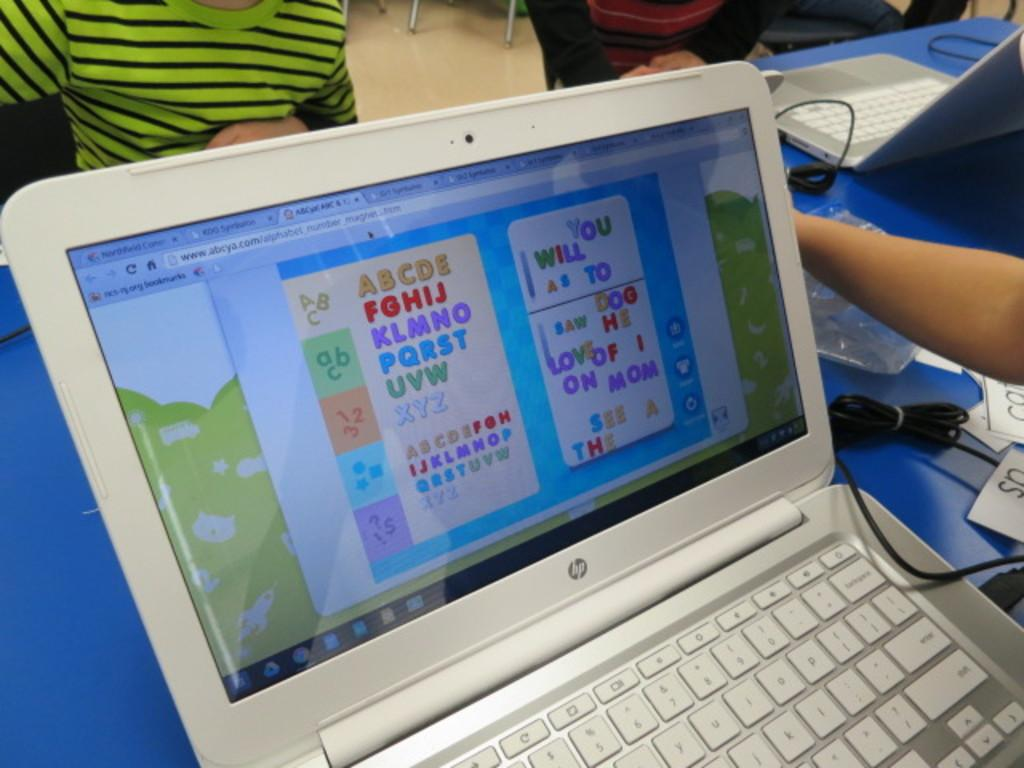Provide a one-sentence caption for the provided image. The alphabet is shown with the word mom spelled out. 